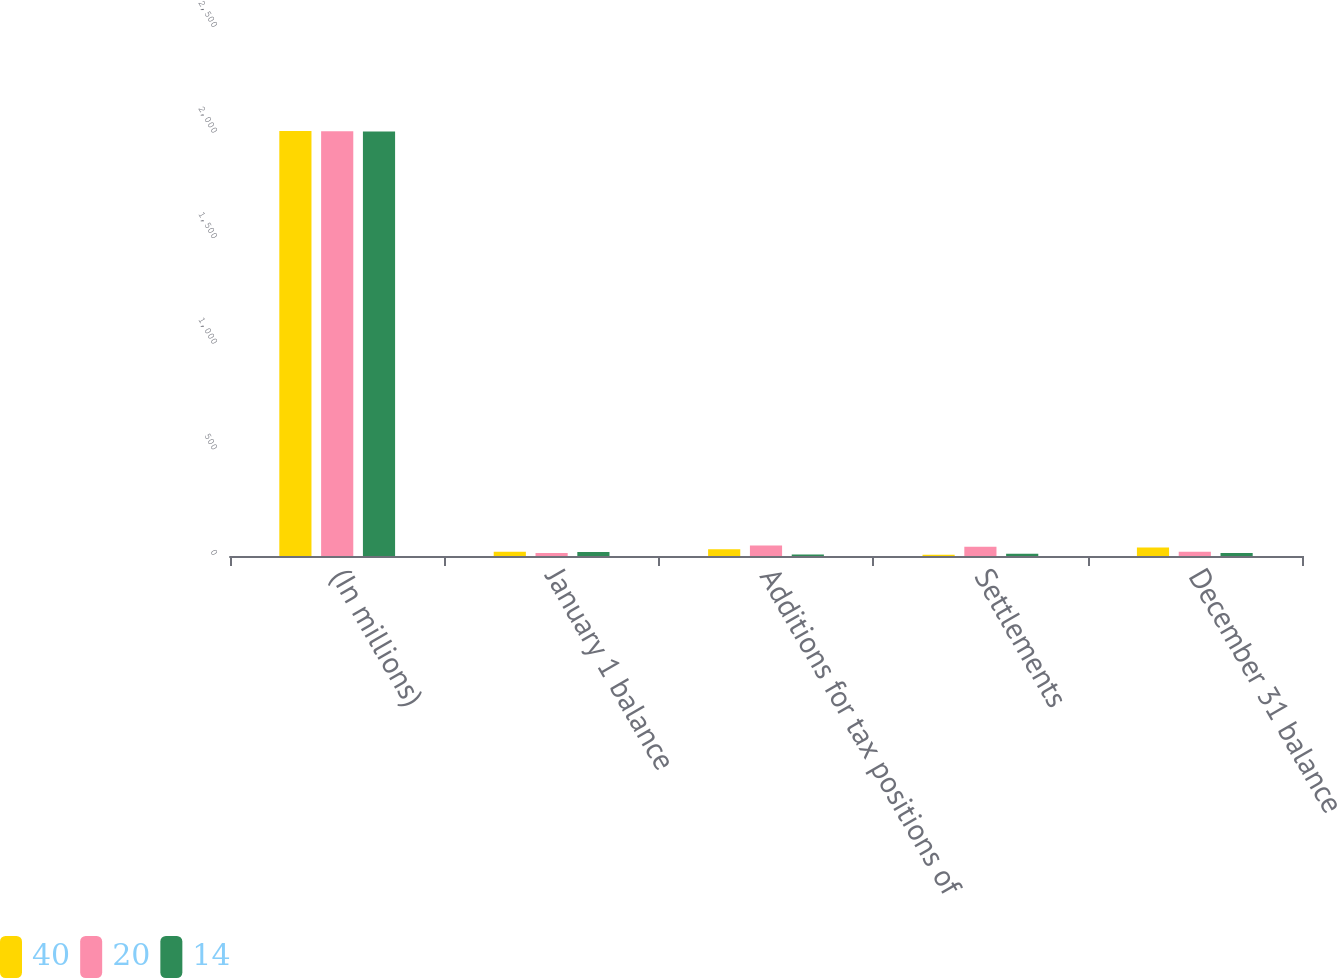<chart> <loc_0><loc_0><loc_500><loc_500><stacked_bar_chart><ecel><fcel>(In millions)<fcel>January 1 balance<fcel>Additions for tax positions of<fcel>Settlements<fcel>December 31 balance<nl><fcel>40<fcel>2012<fcel>20<fcel>32<fcel>6<fcel>40<nl><fcel>20<fcel>2011<fcel>14<fcel>50<fcel>44<fcel>20<nl><fcel>14<fcel>2010<fcel>19<fcel>7<fcel>11<fcel>14<nl></chart> 